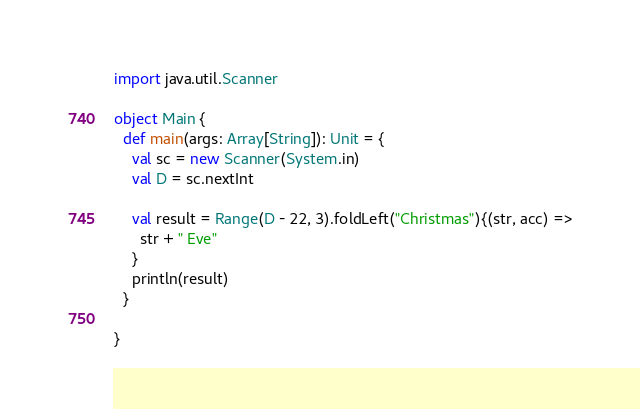<code> <loc_0><loc_0><loc_500><loc_500><_Scala_>import java.util.Scanner

object Main {
  def main(args: Array[String]): Unit = {
    val sc = new Scanner(System.in)
    val D = sc.nextInt

    val result = Range(D - 22, 3).foldLeft("Christmas"){(str, acc) =>
      str + " Eve"
    }
    println(result)
  }

}
</code> 